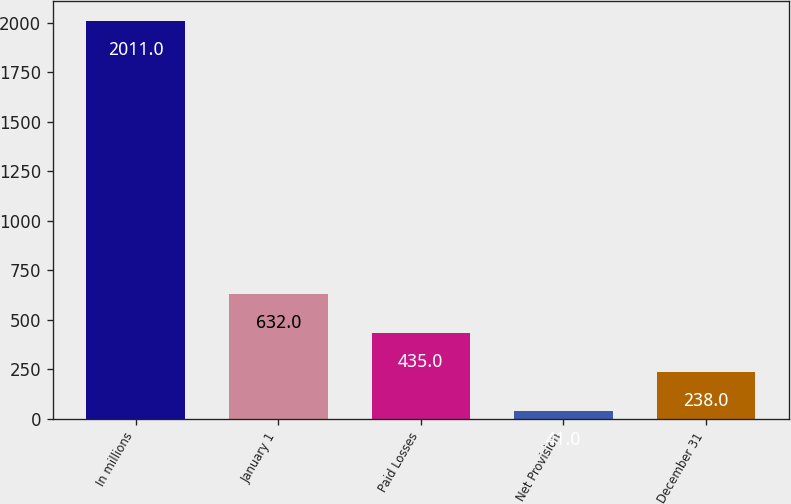Convert chart. <chart><loc_0><loc_0><loc_500><loc_500><bar_chart><fcel>In millions<fcel>January 1<fcel>Paid Losses<fcel>Net Provision<fcel>December 31<nl><fcel>2011<fcel>632<fcel>435<fcel>41<fcel>238<nl></chart> 